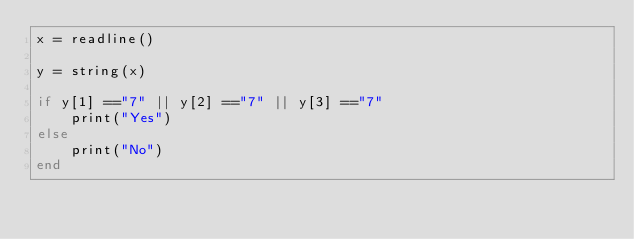<code> <loc_0><loc_0><loc_500><loc_500><_Julia_>x = readline()

y = string(x)

if y[1] =="7" || y[2] =="7" || y[3] =="7"
    print("Yes")
else
    print("No")
end</code> 